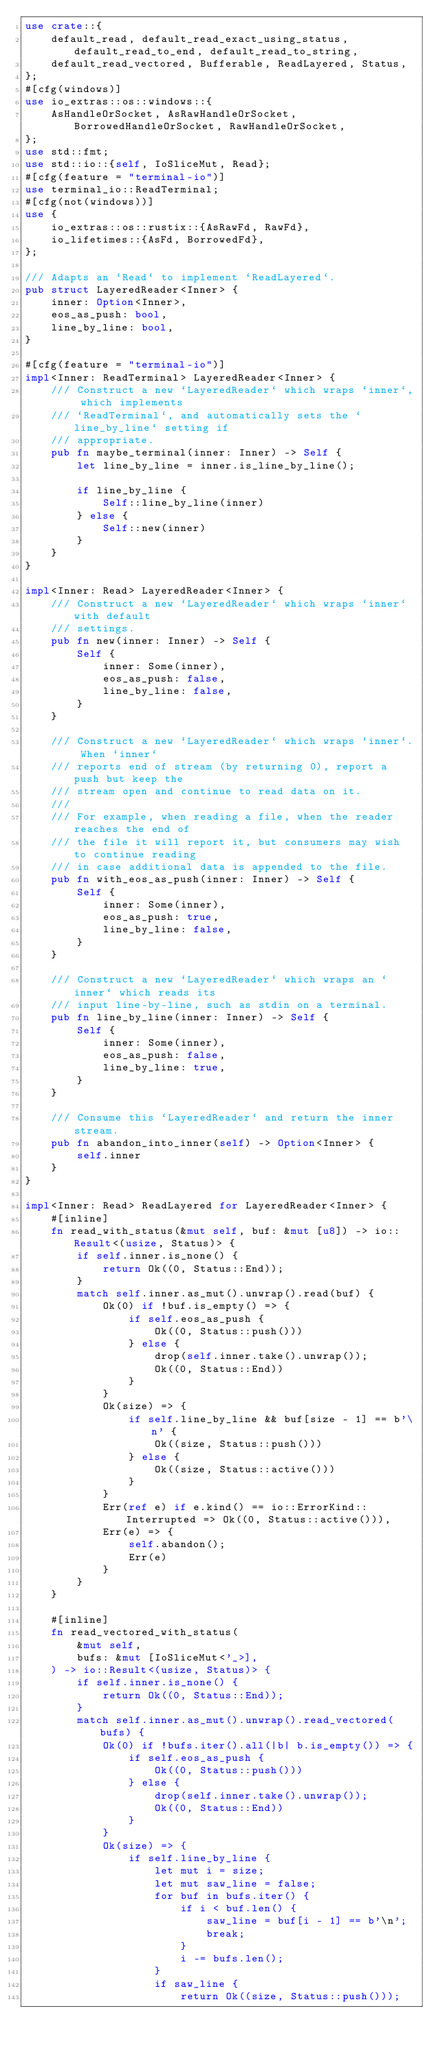Convert code to text. <code><loc_0><loc_0><loc_500><loc_500><_Rust_>use crate::{
    default_read, default_read_exact_using_status, default_read_to_end, default_read_to_string,
    default_read_vectored, Bufferable, ReadLayered, Status,
};
#[cfg(windows)]
use io_extras::os::windows::{
    AsHandleOrSocket, AsRawHandleOrSocket, BorrowedHandleOrSocket, RawHandleOrSocket,
};
use std::fmt;
use std::io::{self, IoSliceMut, Read};
#[cfg(feature = "terminal-io")]
use terminal_io::ReadTerminal;
#[cfg(not(windows))]
use {
    io_extras::os::rustix::{AsRawFd, RawFd},
    io_lifetimes::{AsFd, BorrowedFd},
};

/// Adapts an `Read` to implement `ReadLayered`.
pub struct LayeredReader<Inner> {
    inner: Option<Inner>,
    eos_as_push: bool,
    line_by_line: bool,
}

#[cfg(feature = "terminal-io")]
impl<Inner: ReadTerminal> LayeredReader<Inner> {
    /// Construct a new `LayeredReader` which wraps `inner`, which implements
    /// `ReadTerminal`, and automatically sets the `line_by_line` setting if
    /// appropriate.
    pub fn maybe_terminal(inner: Inner) -> Self {
        let line_by_line = inner.is_line_by_line();

        if line_by_line {
            Self::line_by_line(inner)
        } else {
            Self::new(inner)
        }
    }
}

impl<Inner: Read> LayeredReader<Inner> {
    /// Construct a new `LayeredReader` which wraps `inner` with default
    /// settings.
    pub fn new(inner: Inner) -> Self {
        Self {
            inner: Some(inner),
            eos_as_push: false,
            line_by_line: false,
        }
    }

    /// Construct a new `LayeredReader` which wraps `inner`. When `inner`
    /// reports end of stream (by returning 0), report a push but keep the
    /// stream open and continue to read data on it.
    ///
    /// For example, when reading a file, when the reader reaches the end of
    /// the file it will report it, but consumers may wish to continue reading
    /// in case additional data is appended to the file.
    pub fn with_eos_as_push(inner: Inner) -> Self {
        Self {
            inner: Some(inner),
            eos_as_push: true,
            line_by_line: false,
        }
    }

    /// Construct a new `LayeredReader` which wraps an `inner` which reads its
    /// input line-by-line, such as stdin on a terminal.
    pub fn line_by_line(inner: Inner) -> Self {
        Self {
            inner: Some(inner),
            eos_as_push: false,
            line_by_line: true,
        }
    }

    /// Consume this `LayeredReader` and return the inner stream.
    pub fn abandon_into_inner(self) -> Option<Inner> {
        self.inner
    }
}

impl<Inner: Read> ReadLayered for LayeredReader<Inner> {
    #[inline]
    fn read_with_status(&mut self, buf: &mut [u8]) -> io::Result<(usize, Status)> {
        if self.inner.is_none() {
            return Ok((0, Status::End));
        }
        match self.inner.as_mut().unwrap().read(buf) {
            Ok(0) if !buf.is_empty() => {
                if self.eos_as_push {
                    Ok((0, Status::push()))
                } else {
                    drop(self.inner.take().unwrap());
                    Ok((0, Status::End))
                }
            }
            Ok(size) => {
                if self.line_by_line && buf[size - 1] == b'\n' {
                    Ok((size, Status::push()))
                } else {
                    Ok((size, Status::active()))
                }
            }
            Err(ref e) if e.kind() == io::ErrorKind::Interrupted => Ok((0, Status::active())),
            Err(e) => {
                self.abandon();
                Err(e)
            }
        }
    }

    #[inline]
    fn read_vectored_with_status(
        &mut self,
        bufs: &mut [IoSliceMut<'_>],
    ) -> io::Result<(usize, Status)> {
        if self.inner.is_none() {
            return Ok((0, Status::End));
        }
        match self.inner.as_mut().unwrap().read_vectored(bufs) {
            Ok(0) if !bufs.iter().all(|b| b.is_empty()) => {
                if self.eos_as_push {
                    Ok((0, Status::push()))
                } else {
                    drop(self.inner.take().unwrap());
                    Ok((0, Status::End))
                }
            }
            Ok(size) => {
                if self.line_by_line {
                    let mut i = size;
                    let mut saw_line = false;
                    for buf in bufs.iter() {
                        if i < buf.len() {
                            saw_line = buf[i - 1] == b'\n';
                            break;
                        }
                        i -= bufs.len();
                    }
                    if saw_line {
                        return Ok((size, Status::push()));</code> 